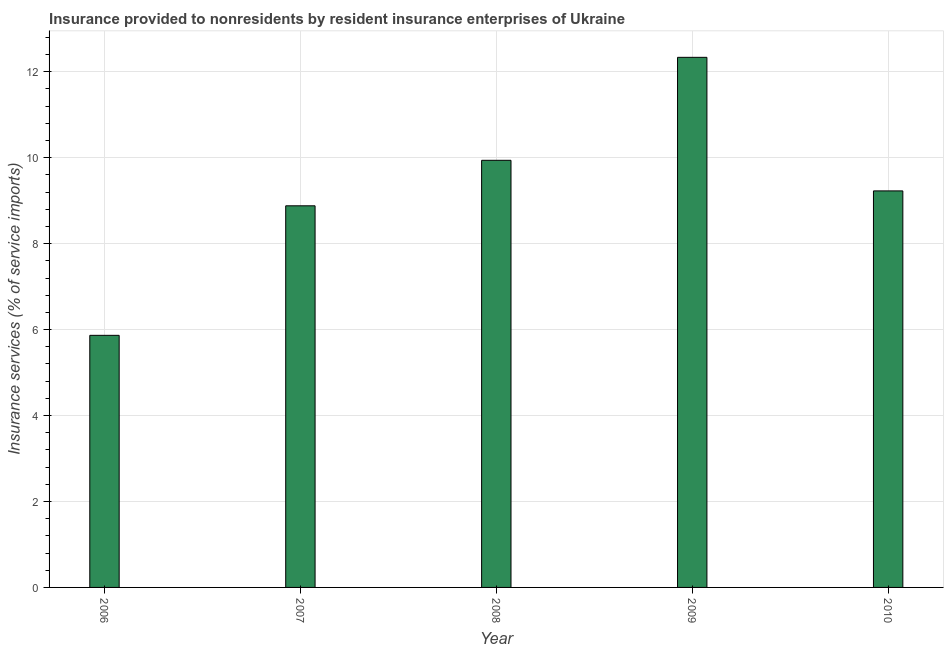What is the title of the graph?
Your answer should be very brief. Insurance provided to nonresidents by resident insurance enterprises of Ukraine. What is the label or title of the X-axis?
Your response must be concise. Year. What is the label or title of the Y-axis?
Provide a succinct answer. Insurance services (% of service imports). What is the insurance and financial services in 2006?
Your answer should be very brief. 5.87. Across all years, what is the maximum insurance and financial services?
Your answer should be compact. 12.34. Across all years, what is the minimum insurance and financial services?
Your response must be concise. 5.87. In which year was the insurance and financial services maximum?
Your response must be concise. 2009. What is the sum of the insurance and financial services?
Offer a very short reply. 46.25. What is the difference between the insurance and financial services in 2006 and 2007?
Your response must be concise. -3.01. What is the average insurance and financial services per year?
Keep it short and to the point. 9.25. What is the median insurance and financial services?
Ensure brevity in your answer.  9.23. Do a majority of the years between 2009 and 2010 (inclusive) have insurance and financial services greater than 10.4 %?
Provide a succinct answer. No. What is the ratio of the insurance and financial services in 2006 to that in 2008?
Provide a succinct answer. 0.59. Is the difference between the insurance and financial services in 2007 and 2008 greater than the difference between any two years?
Your answer should be compact. No. What is the difference between the highest and the second highest insurance and financial services?
Make the answer very short. 2.4. Is the sum of the insurance and financial services in 2009 and 2010 greater than the maximum insurance and financial services across all years?
Give a very brief answer. Yes. What is the difference between the highest and the lowest insurance and financial services?
Offer a terse response. 6.47. How many bars are there?
Offer a terse response. 5. How many years are there in the graph?
Your answer should be compact. 5. What is the Insurance services (% of service imports) of 2006?
Give a very brief answer. 5.87. What is the Insurance services (% of service imports) in 2007?
Keep it short and to the point. 8.88. What is the Insurance services (% of service imports) in 2008?
Your answer should be compact. 9.94. What is the Insurance services (% of service imports) of 2009?
Make the answer very short. 12.34. What is the Insurance services (% of service imports) of 2010?
Offer a very short reply. 9.23. What is the difference between the Insurance services (% of service imports) in 2006 and 2007?
Your answer should be very brief. -3.01. What is the difference between the Insurance services (% of service imports) in 2006 and 2008?
Provide a succinct answer. -4.07. What is the difference between the Insurance services (% of service imports) in 2006 and 2009?
Give a very brief answer. -6.47. What is the difference between the Insurance services (% of service imports) in 2006 and 2010?
Make the answer very short. -3.36. What is the difference between the Insurance services (% of service imports) in 2007 and 2008?
Ensure brevity in your answer.  -1.06. What is the difference between the Insurance services (% of service imports) in 2007 and 2009?
Your response must be concise. -3.46. What is the difference between the Insurance services (% of service imports) in 2007 and 2010?
Your answer should be compact. -0.35. What is the difference between the Insurance services (% of service imports) in 2008 and 2009?
Provide a short and direct response. -2.4. What is the difference between the Insurance services (% of service imports) in 2008 and 2010?
Ensure brevity in your answer.  0.71. What is the difference between the Insurance services (% of service imports) in 2009 and 2010?
Provide a short and direct response. 3.11. What is the ratio of the Insurance services (% of service imports) in 2006 to that in 2007?
Provide a short and direct response. 0.66. What is the ratio of the Insurance services (% of service imports) in 2006 to that in 2008?
Keep it short and to the point. 0.59. What is the ratio of the Insurance services (% of service imports) in 2006 to that in 2009?
Your answer should be compact. 0.48. What is the ratio of the Insurance services (% of service imports) in 2006 to that in 2010?
Your answer should be compact. 0.64. What is the ratio of the Insurance services (% of service imports) in 2007 to that in 2008?
Offer a very short reply. 0.89. What is the ratio of the Insurance services (% of service imports) in 2007 to that in 2009?
Ensure brevity in your answer.  0.72. What is the ratio of the Insurance services (% of service imports) in 2008 to that in 2009?
Provide a succinct answer. 0.81. What is the ratio of the Insurance services (% of service imports) in 2008 to that in 2010?
Give a very brief answer. 1.08. What is the ratio of the Insurance services (% of service imports) in 2009 to that in 2010?
Your response must be concise. 1.34. 